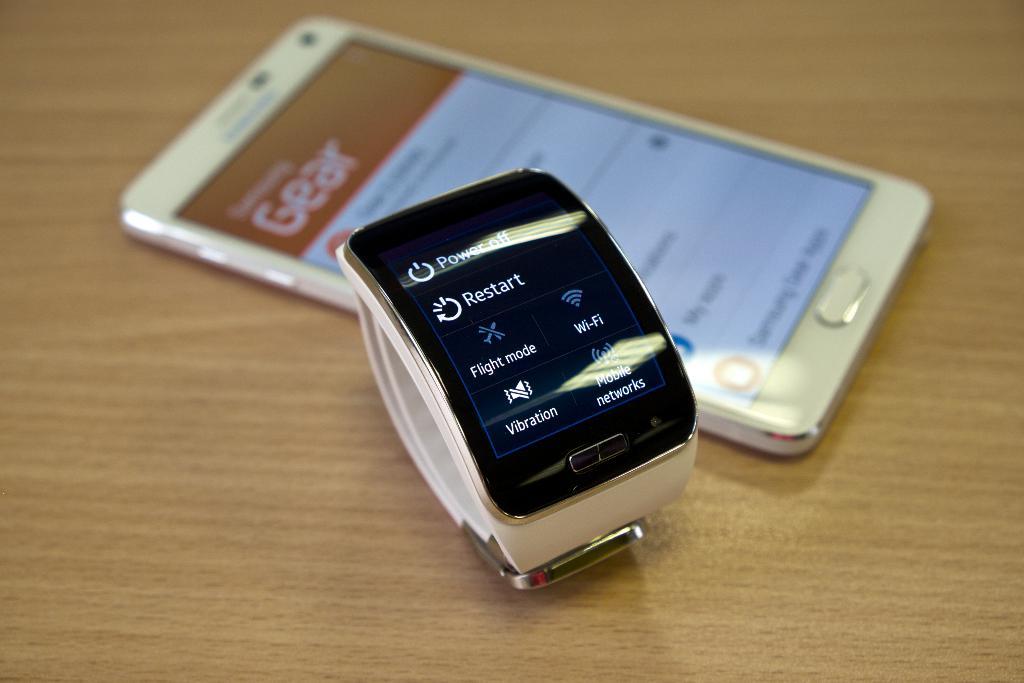What is the word beneath the bottom left symbol?
Ensure brevity in your answer.  Vibration. 